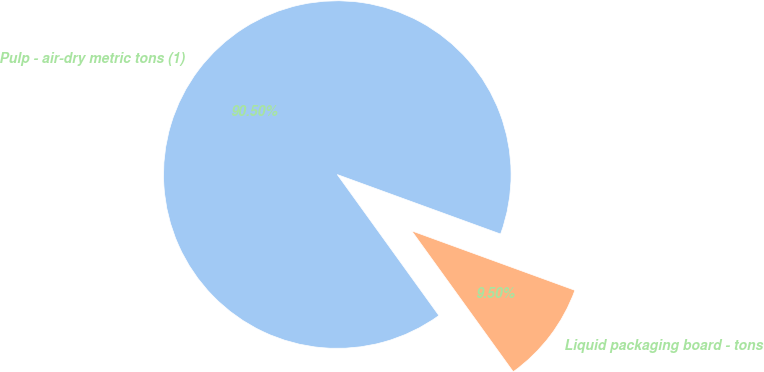Convert chart to OTSL. <chart><loc_0><loc_0><loc_500><loc_500><pie_chart><fcel>Pulp - air-dry metric tons (1)<fcel>Liquid packaging board - tons<nl><fcel>90.5%<fcel>9.5%<nl></chart> 